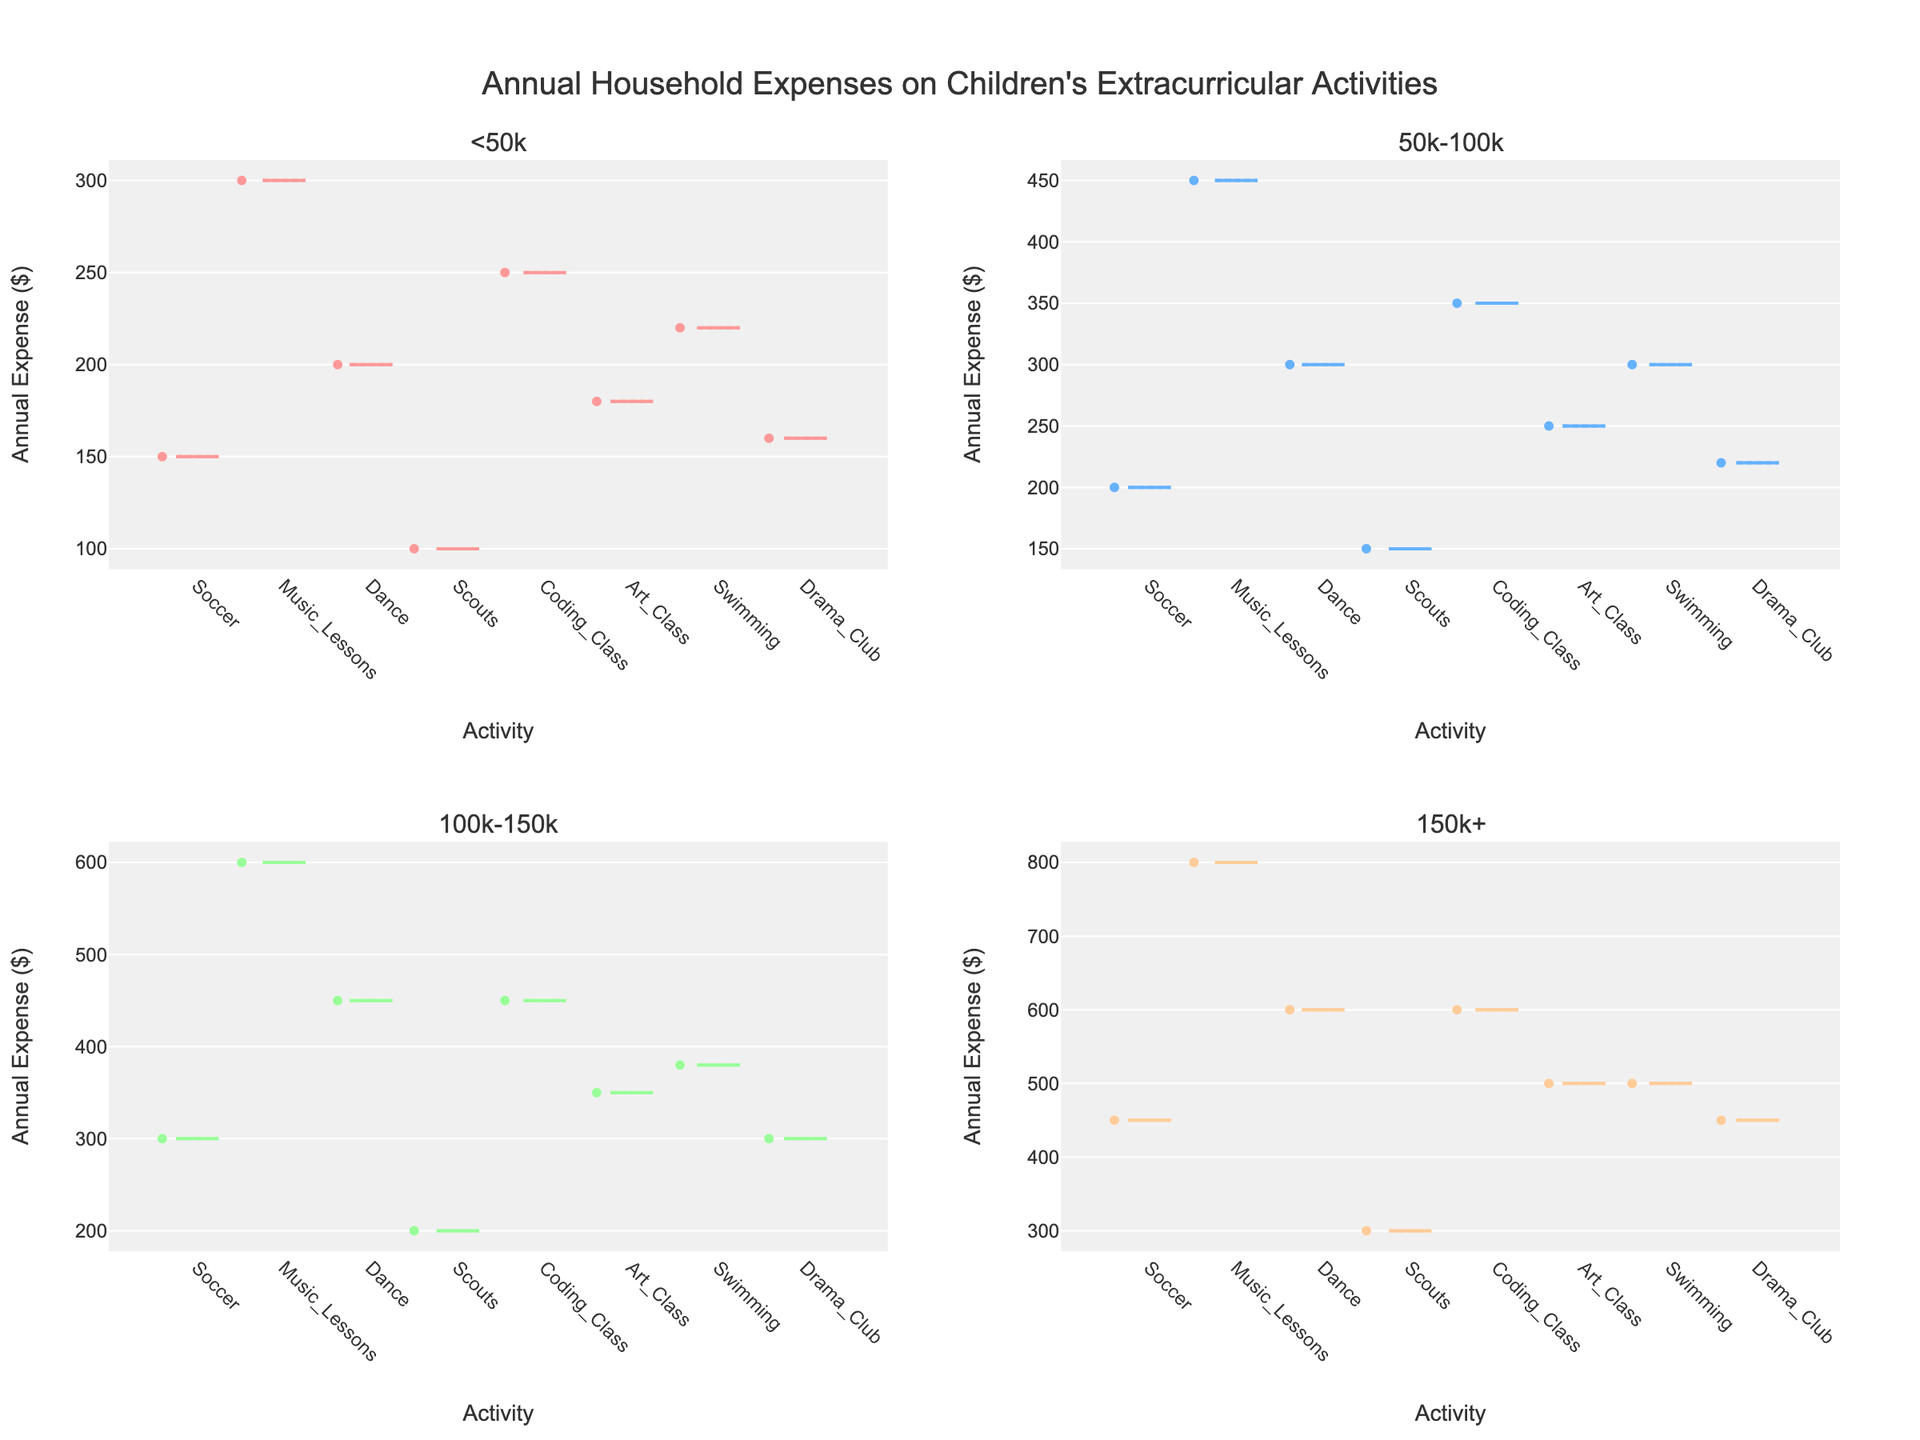what's the title of the figure? The title of the figure is usually displayed at the top. In this figure, it reads "Annual Household Expenses on Children's Extracurricular Activities".
Answer: Annual Household Expenses on Children's Extracurricular Activities what's the range of the annual expense in the "<50k" income bracket subplot? To find the range, we look at the minimum and maximum values of annual expenses in the "<50k" income bracket subplot. The minimum is 100, and the maximum is 300. The range is the difference between these values, which is 300 - 100.
Answer: 200 Which income bracket spends the most on music lessons on average? By looking at the music lessons box plots across the different income brackets, the average can be observed where the box is centered. The income bracket "150k+" has its average (mean) plotted for music lessons higher than the others at 800.
Answer: 150k+ How does the spending on Coding Class differ between the "<50k" and "50k-100k" income brackets? In the "<50k" income bracket, the median spending on Coding Class is significantly lower than in the "50k-100k" income bracket. We need to compare the medians or average values, "<50k" has a median of around 250, while "50k-100k" is around 350.
Answer: 100 more for "50k-100k" Which activity seems to have the most consistent spending regardless of income bracket? An activity with the most consistent spending will have the smallest variance in its box plots across all income brackets. Scouts have relatively small boxes (indicating less variance/spread) across all income brackets.
Answer: Scouts In the "100k-150k" bracket, which activity has the highest annual expense? Looking at the "100k-150k" income bracket, the box with the highest annual expense means the highest point on its chart. Music Lessons have the highest expense at 600.
Answer: Music Lessons How does the range of expenses on Drama Club in the "150k+" bracket compare to that in the "<50k" bracket? To determine this, we find the range (max-min) for Drama Club in both brackets "<50k" and "150k+". In "<50k", the range is 160-150=10, while in "150k+", the range is 450-450=0.
Answer: "<50k" has a wider range Which bracket spends the least on Soccer? Identify the lowest median value in the Soccer category among all brackets. The "<50k" income bracket has the lowest median spending, at 150.
Answer: <50k 